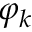<formula> <loc_0><loc_0><loc_500><loc_500>\varphi _ { k }</formula> 